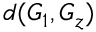Convert formula to latex. <formula><loc_0><loc_0><loc_500><loc_500>d ( G _ { 1 } , G _ { z } )</formula> 